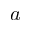<formula> <loc_0><loc_0><loc_500><loc_500>a</formula> 